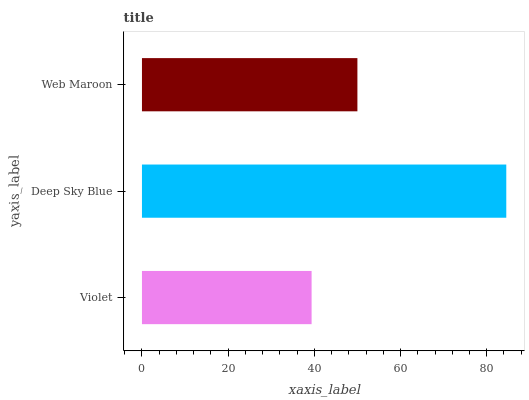Is Violet the minimum?
Answer yes or no. Yes. Is Deep Sky Blue the maximum?
Answer yes or no. Yes. Is Web Maroon the minimum?
Answer yes or no. No. Is Web Maroon the maximum?
Answer yes or no. No. Is Deep Sky Blue greater than Web Maroon?
Answer yes or no. Yes. Is Web Maroon less than Deep Sky Blue?
Answer yes or no. Yes. Is Web Maroon greater than Deep Sky Blue?
Answer yes or no. No. Is Deep Sky Blue less than Web Maroon?
Answer yes or no. No. Is Web Maroon the high median?
Answer yes or no. Yes. Is Web Maroon the low median?
Answer yes or no. Yes. Is Deep Sky Blue the high median?
Answer yes or no. No. Is Violet the low median?
Answer yes or no. No. 